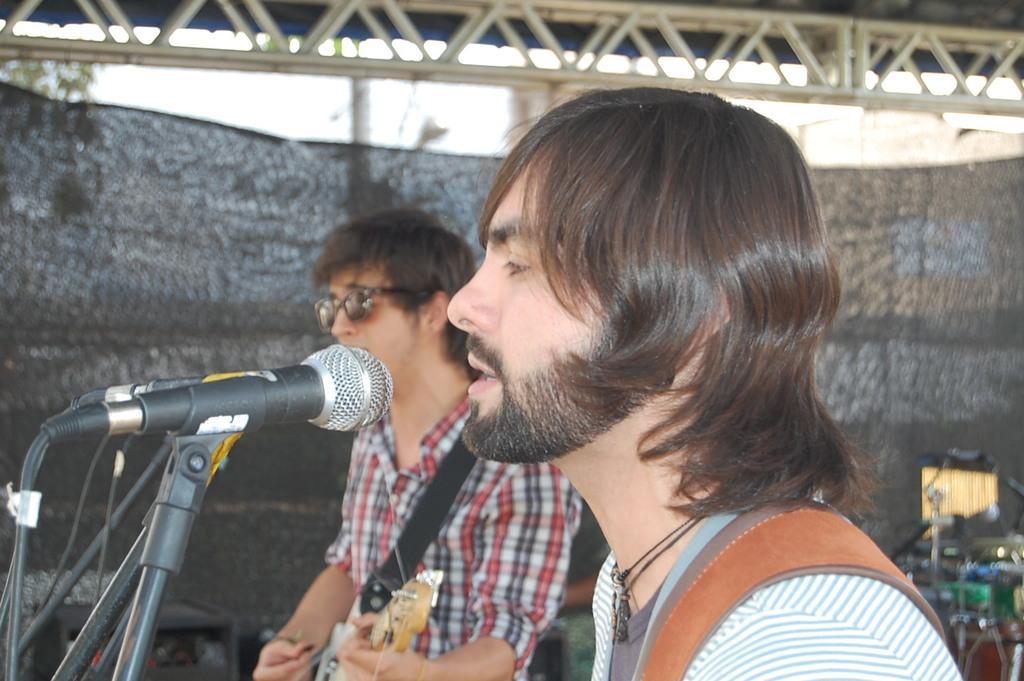How would you summarize this image in a sentence or two? In the foreground area of this image, there is a man in the center of the image and there are mics in front of him and there is another man, by holding a guitar in his hand and there are musical instruments and a curtain in the background area, there is a pole, tree, and sky at the top side. 